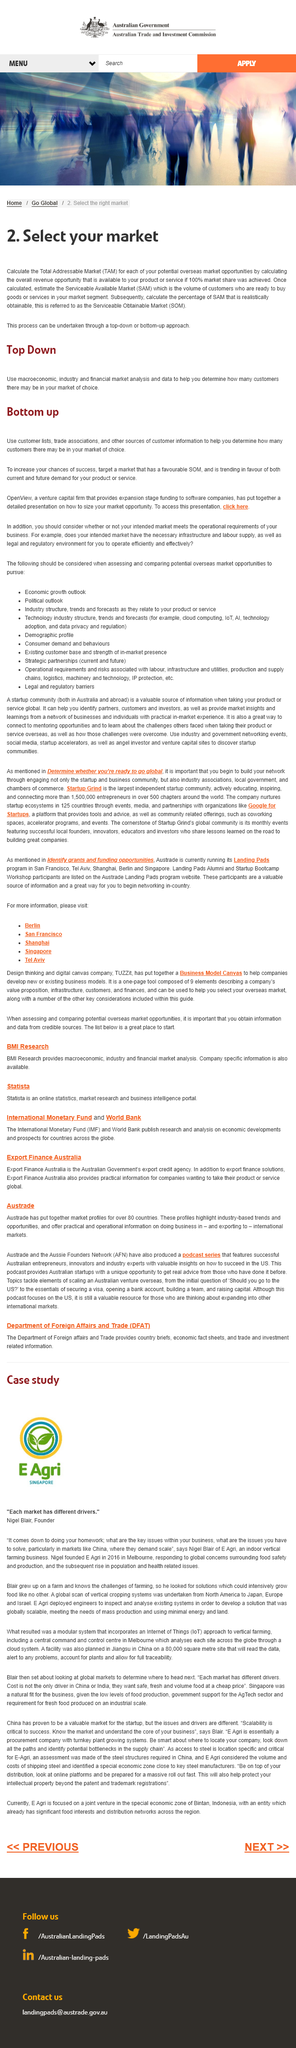List a handful of essential elements in this visual. SAM stands for Serviceable Available Market, a term used to describe the potential customer base that a product or service can target and sell to. Total Addressable Market" refers to the total potential revenue that can be generated from selling a product or service to a specific target market. It is a critical metric used by businesses to identify market opportunities and guide strategic decision-making. When selecting a market, the Total Available Market (TAM), Serviceable Available Market (SAM), and Serviceable Obtainable Market (SOM) can be identified through a top-down or bottom-up approach. 